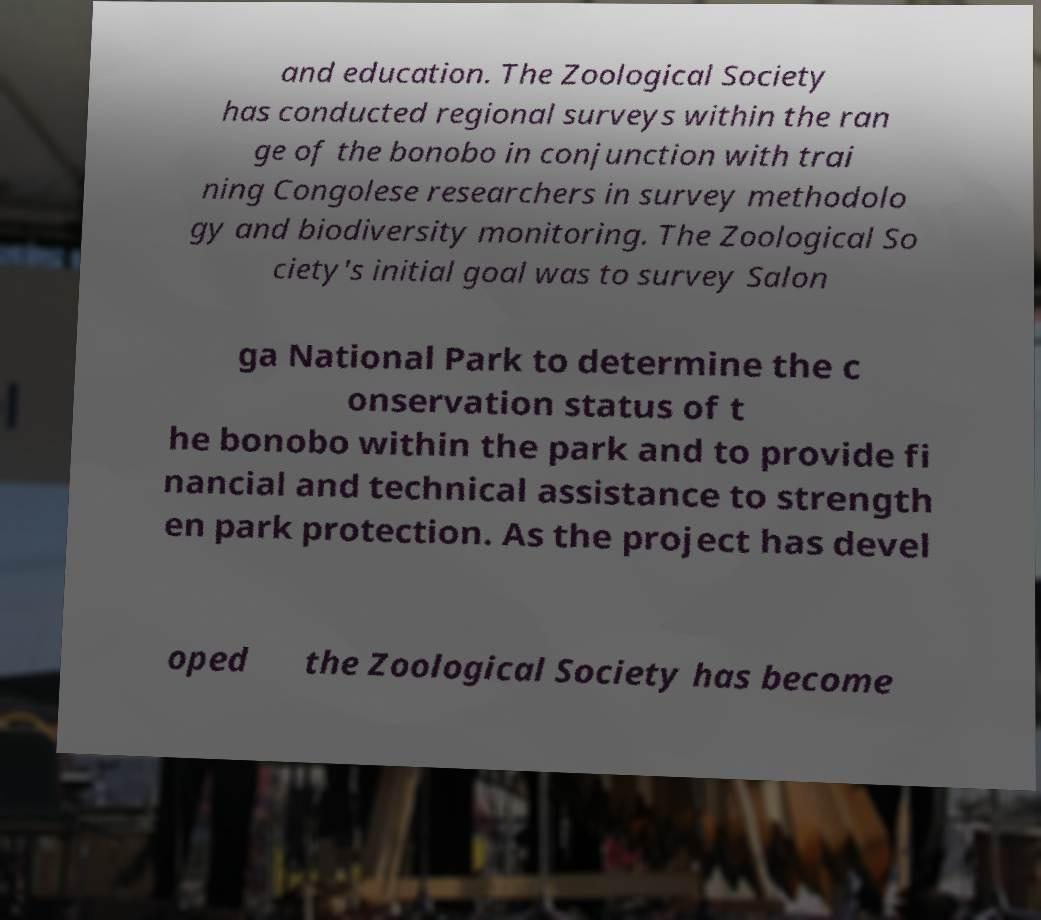Can you accurately transcribe the text from the provided image for me? and education. The Zoological Society has conducted regional surveys within the ran ge of the bonobo in conjunction with trai ning Congolese researchers in survey methodolo gy and biodiversity monitoring. The Zoological So ciety's initial goal was to survey Salon ga National Park to determine the c onservation status of t he bonobo within the park and to provide fi nancial and technical assistance to strength en park protection. As the project has devel oped the Zoological Society has become 